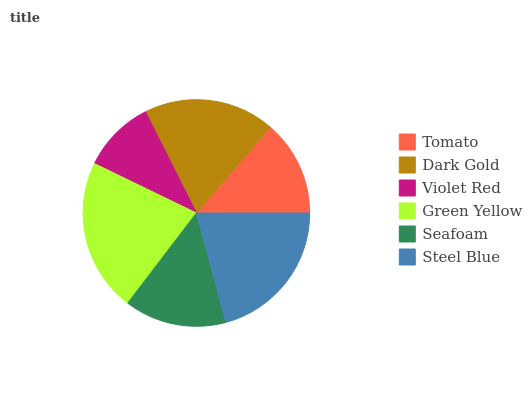Is Violet Red the minimum?
Answer yes or no. Yes. Is Green Yellow the maximum?
Answer yes or no. Yes. Is Dark Gold the minimum?
Answer yes or no. No. Is Dark Gold the maximum?
Answer yes or no. No. Is Dark Gold greater than Tomato?
Answer yes or no. Yes. Is Tomato less than Dark Gold?
Answer yes or no. Yes. Is Tomato greater than Dark Gold?
Answer yes or no. No. Is Dark Gold less than Tomato?
Answer yes or no. No. Is Dark Gold the high median?
Answer yes or no. Yes. Is Seafoam the low median?
Answer yes or no. Yes. Is Violet Red the high median?
Answer yes or no. No. Is Steel Blue the low median?
Answer yes or no. No. 